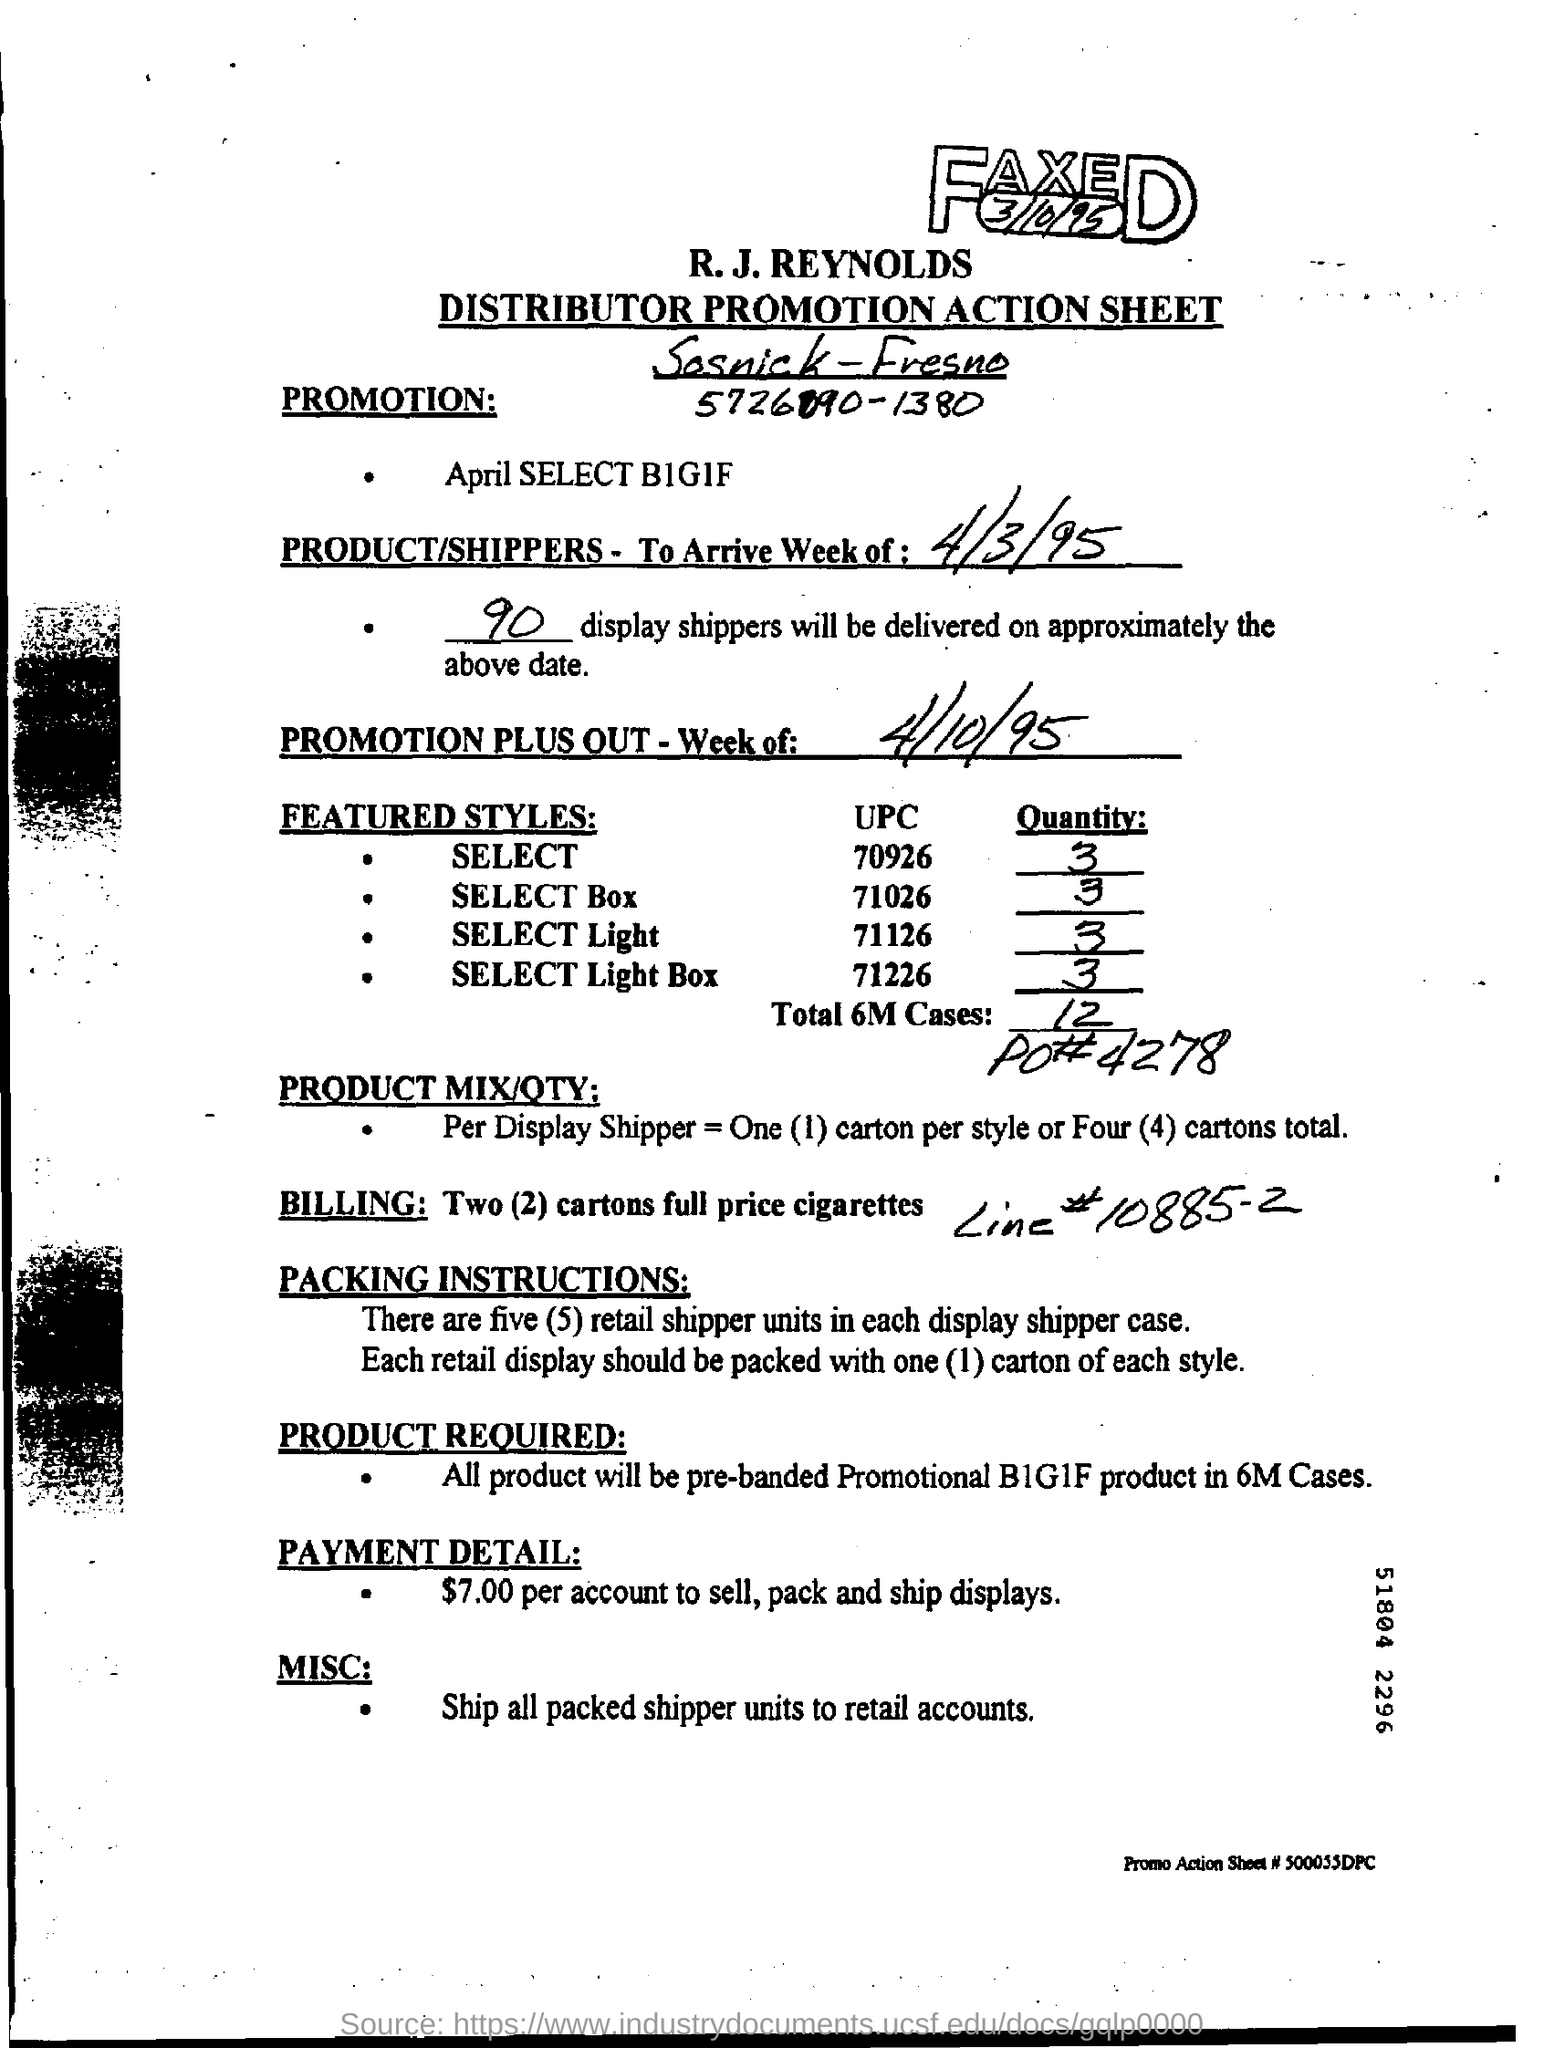All packed shipper units are shipped to which accounts?
Make the answer very short. Retail. How many retail shipper units are there in each display shipper case?
Give a very brief answer. Five (5). 